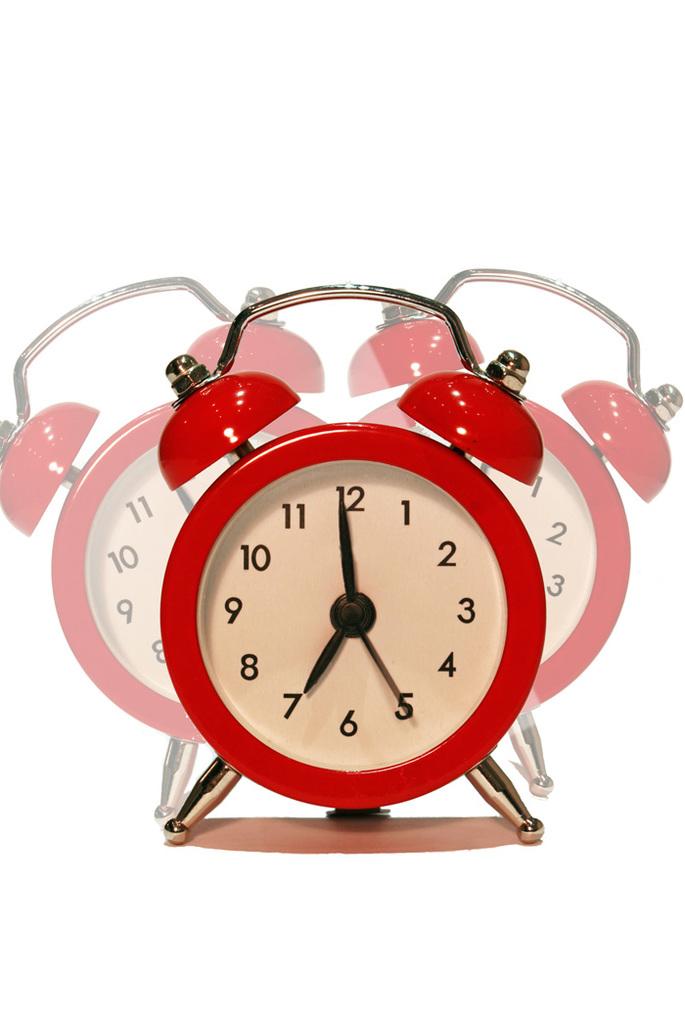What time is on the red alarm clock?
Offer a terse response. 6:59. 